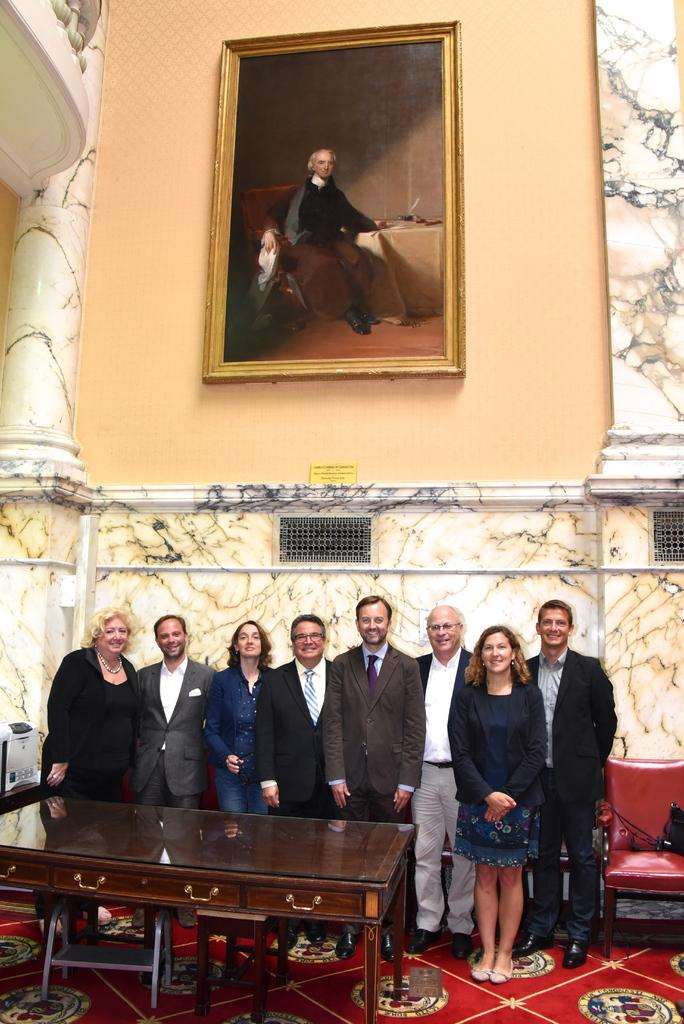What is hanging on the wall in the image? There is a picture on the wall. What are the persons in the image doing? The persons are standing and giving stills. What object is in front of the persons? There is a table in front of them. What color is the chair visible in the image? A red chair is visible in the image. Which direction is the north indicated in the image? There is no indication of direction, such as north, in the image. How many pages are visible in the image? There are no pages present in the image. 